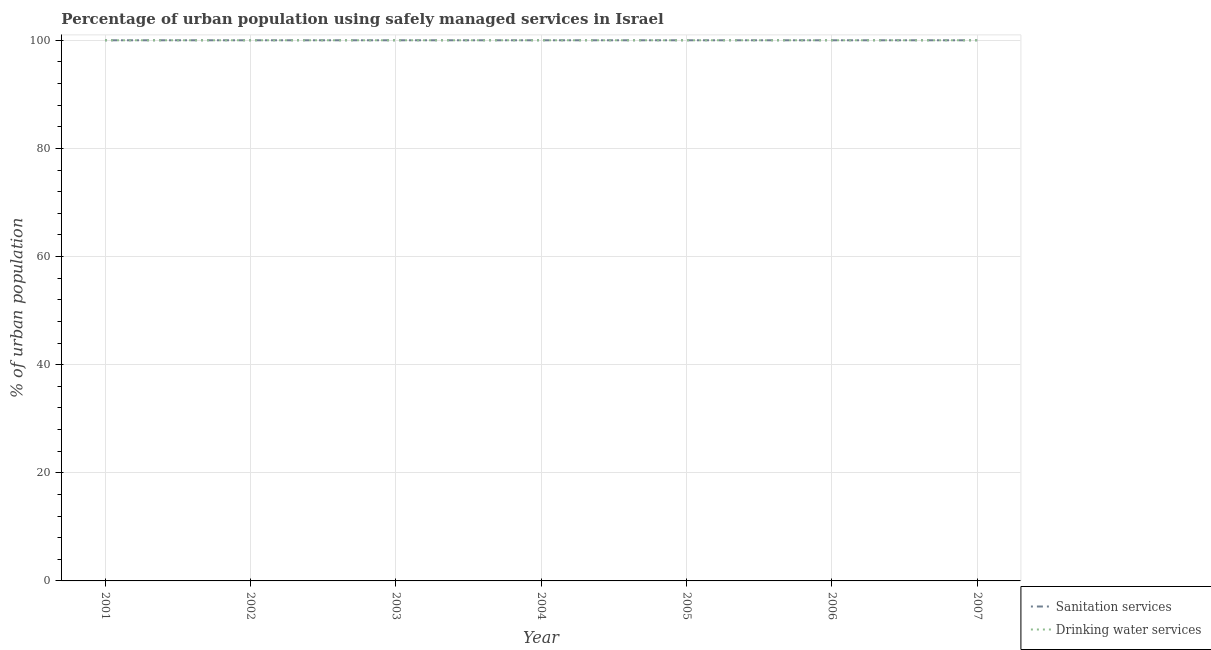What is the percentage of urban population who used drinking water services in 2005?
Your response must be concise. 100. Across all years, what is the maximum percentage of urban population who used drinking water services?
Offer a very short reply. 100. Across all years, what is the minimum percentage of urban population who used drinking water services?
Give a very brief answer. 100. In which year was the percentage of urban population who used sanitation services maximum?
Provide a short and direct response. 2001. In which year was the percentage of urban population who used drinking water services minimum?
Give a very brief answer. 2001. What is the total percentage of urban population who used drinking water services in the graph?
Your response must be concise. 700. What is the difference between the percentage of urban population who used sanitation services in 2002 and the percentage of urban population who used drinking water services in 2006?
Your response must be concise. 0. What is the ratio of the percentage of urban population who used sanitation services in 2004 to that in 2006?
Offer a terse response. 1. Is the percentage of urban population who used drinking water services in 2004 less than that in 2007?
Ensure brevity in your answer.  No. What is the difference between the highest and the second highest percentage of urban population who used sanitation services?
Keep it short and to the point. 0. What is the difference between the highest and the lowest percentage of urban population who used sanitation services?
Give a very brief answer. 0. In how many years, is the percentage of urban population who used sanitation services greater than the average percentage of urban population who used sanitation services taken over all years?
Make the answer very short. 0. Is the sum of the percentage of urban population who used drinking water services in 2005 and 2006 greater than the maximum percentage of urban population who used sanitation services across all years?
Offer a very short reply. Yes. Does the percentage of urban population who used sanitation services monotonically increase over the years?
Your answer should be very brief. No. Is the percentage of urban population who used sanitation services strictly greater than the percentage of urban population who used drinking water services over the years?
Give a very brief answer. No. How many lines are there?
Your answer should be very brief. 2. Does the graph contain any zero values?
Keep it short and to the point. No. Where does the legend appear in the graph?
Your answer should be very brief. Bottom right. How many legend labels are there?
Your response must be concise. 2. How are the legend labels stacked?
Give a very brief answer. Vertical. What is the title of the graph?
Provide a succinct answer. Percentage of urban population using safely managed services in Israel. Does "Study and work" appear as one of the legend labels in the graph?
Provide a succinct answer. No. What is the label or title of the X-axis?
Ensure brevity in your answer.  Year. What is the label or title of the Y-axis?
Provide a short and direct response. % of urban population. What is the % of urban population of Sanitation services in 2001?
Provide a succinct answer. 100. What is the % of urban population in Drinking water services in 2002?
Keep it short and to the point. 100. What is the % of urban population in Drinking water services in 2003?
Ensure brevity in your answer.  100. What is the % of urban population of Drinking water services in 2004?
Offer a very short reply. 100. What is the % of urban population of Sanitation services in 2006?
Make the answer very short. 100. Across all years, what is the maximum % of urban population in Drinking water services?
Offer a terse response. 100. Across all years, what is the minimum % of urban population of Sanitation services?
Your response must be concise. 100. What is the total % of urban population in Sanitation services in the graph?
Offer a very short reply. 700. What is the total % of urban population of Drinking water services in the graph?
Keep it short and to the point. 700. What is the difference between the % of urban population of Drinking water services in 2001 and that in 2002?
Ensure brevity in your answer.  0. What is the difference between the % of urban population in Sanitation services in 2001 and that in 2003?
Offer a terse response. 0. What is the difference between the % of urban population in Sanitation services in 2001 and that in 2004?
Offer a very short reply. 0. What is the difference between the % of urban population of Sanitation services in 2001 and that in 2005?
Keep it short and to the point. 0. What is the difference between the % of urban population of Drinking water services in 2001 and that in 2005?
Keep it short and to the point. 0. What is the difference between the % of urban population of Sanitation services in 2001 and that in 2006?
Keep it short and to the point. 0. What is the difference between the % of urban population in Sanitation services in 2001 and that in 2007?
Provide a succinct answer. 0. What is the difference between the % of urban population in Drinking water services in 2001 and that in 2007?
Offer a terse response. 0. What is the difference between the % of urban population of Sanitation services in 2002 and that in 2003?
Provide a short and direct response. 0. What is the difference between the % of urban population of Sanitation services in 2002 and that in 2004?
Your response must be concise. 0. What is the difference between the % of urban population of Sanitation services in 2002 and that in 2005?
Your response must be concise. 0. What is the difference between the % of urban population in Drinking water services in 2002 and that in 2006?
Offer a terse response. 0. What is the difference between the % of urban population in Drinking water services in 2003 and that in 2005?
Your answer should be compact. 0. What is the difference between the % of urban population in Sanitation services in 2003 and that in 2006?
Your answer should be very brief. 0. What is the difference between the % of urban population of Drinking water services in 2003 and that in 2006?
Give a very brief answer. 0. What is the difference between the % of urban population in Sanitation services in 2003 and that in 2007?
Provide a short and direct response. 0. What is the difference between the % of urban population of Drinking water services in 2004 and that in 2006?
Provide a succinct answer. 0. What is the difference between the % of urban population in Drinking water services in 2004 and that in 2007?
Give a very brief answer. 0. What is the difference between the % of urban population of Sanitation services in 2005 and that in 2006?
Keep it short and to the point. 0. What is the difference between the % of urban population in Drinking water services in 2005 and that in 2007?
Make the answer very short. 0. What is the difference between the % of urban population of Drinking water services in 2006 and that in 2007?
Offer a terse response. 0. What is the difference between the % of urban population of Sanitation services in 2001 and the % of urban population of Drinking water services in 2002?
Provide a succinct answer. 0. What is the difference between the % of urban population of Sanitation services in 2001 and the % of urban population of Drinking water services in 2005?
Make the answer very short. 0. What is the difference between the % of urban population of Sanitation services in 2001 and the % of urban population of Drinking water services in 2006?
Ensure brevity in your answer.  0. What is the difference between the % of urban population in Sanitation services in 2002 and the % of urban population in Drinking water services in 2005?
Offer a very short reply. 0. What is the difference between the % of urban population of Sanitation services in 2002 and the % of urban population of Drinking water services in 2007?
Give a very brief answer. 0. What is the difference between the % of urban population of Sanitation services in 2003 and the % of urban population of Drinking water services in 2004?
Keep it short and to the point. 0. What is the difference between the % of urban population in Sanitation services in 2003 and the % of urban population in Drinking water services in 2005?
Give a very brief answer. 0. What is the difference between the % of urban population in Sanitation services in 2003 and the % of urban population in Drinking water services in 2007?
Give a very brief answer. 0. What is the difference between the % of urban population in Sanitation services in 2004 and the % of urban population in Drinking water services in 2007?
Ensure brevity in your answer.  0. What is the difference between the % of urban population in Sanitation services in 2005 and the % of urban population in Drinking water services in 2006?
Keep it short and to the point. 0. What is the difference between the % of urban population of Sanitation services in 2005 and the % of urban population of Drinking water services in 2007?
Your answer should be compact. 0. What is the difference between the % of urban population in Sanitation services in 2006 and the % of urban population in Drinking water services in 2007?
Your answer should be compact. 0. What is the average % of urban population in Sanitation services per year?
Your answer should be compact. 100. In the year 2001, what is the difference between the % of urban population in Sanitation services and % of urban population in Drinking water services?
Your answer should be very brief. 0. In the year 2002, what is the difference between the % of urban population in Sanitation services and % of urban population in Drinking water services?
Provide a succinct answer. 0. In the year 2007, what is the difference between the % of urban population in Sanitation services and % of urban population in Drinking water services?
Give a very brief answer. 0. What is the ratio of the % of urban population of Sanitation services in 2001 to that in 2002?
Offer a terse response. 1. What is the ratio of the % of urban population in Sanitation services in 2001 to that in 2003?
Ensure brevity in your answer.  1. What is the ratio of the % of urban population in Sanitation services in 2001 to that in 2004?
Your response must be concise. 1. What is the ratio of the % of urban population of Sanitation services in 2001 to that in 2007?
Provide a succinct answer. 1. What is the ratio of the % of urban population of Sanitation services in 2002 to that in 2003?
Make the answer very short. 1. What is the ratio of the % of urban population of Sanitation services in 2002 to that in 2004?
Provide a succinct answer. 1. What is the ratio of the % of urban population in Drinking water services in 2002 to that in 2006?
Ensure brevity in your answer.  1. What is the ratio of the % of urban population in Drinking water services in 2002 to that in 2007?
Offer a very short reply. 1. What is the ratio of the % of urban population of Sanitation services in 2003 to that in 2004?
Your response must be concise. 1. What is the ratio of the % of urban population of Drinking water services in 2003 to that in 2004?
Your answer should be very brief. 1. What is the ratio of the % of urban population in Drinking water services in 2003 to that in 2005?
Provide a short and direct response. 1. What is the ratio of the % of urban population in Drinking water services in 2003 to that in 2006?
Your answer should be very brief. 1. What is the ratio of the % of urban population of Drinking water services in 2003 to that in 2007?
Your response must be concise. 1. What is the ratio of the % of urban population in Drinking water services in 2004 to that in 2005?
Provide a short and direct response. 1. What is the ratio of the % of urban population in Sanitation services in 2004 to that in 2006?
Ensure brevity in your answer.  1. What is the ratio of the % of urban population in Drinking water services in 2004 to that in 2006?
Make the answer very short. 1. What is the ratio of the % of urban population in Sanitation services in 2004 to that in 2007?
Offer a very short reply. 1. What is the ratio of the % of urban population in Drinking water services in 2004 to that in 2007?
Offer a terse response. 1. What is the ratio of the % of urban population of Drinking water services in 2005 to that in 2006?
Your answer should be very brief. 1. What is the ratio of the % of urban population of Drinking water services in 2005 to that in 2007?
Your response must be concise. 1. What is the ratio of the % of urban population in Sanitation services in 2006 to that in 2007?
Keep it short and to the point. 1. What is the difference between the highest and the lowest % of urban population in Sanitation services?
Keep it short and to the point. 0. What is the difference between the highest and the lowest % of urban population of Drinking water services?
Your response must be concise. 0. 